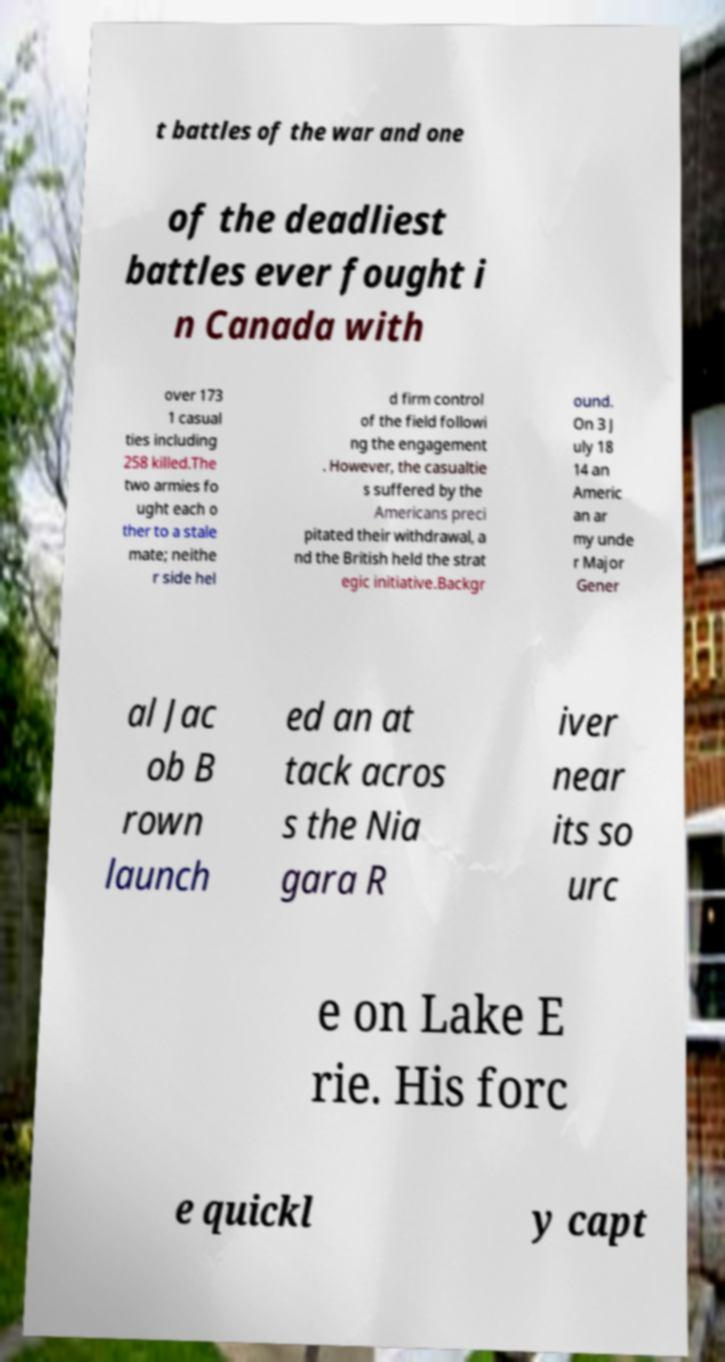Please identify and transcribe the text found in this image. t battles of the war and one of the deadliest battles ever fought i n Canada with over 173 1 casual ties including 258 killed.The two armies fo ught each o ther to a stale mate; neithe r side hel d firm control of the field followi ng the engagement . However, the casualtie s suffered by the Americans preci pitated their withdrawal, a nd the British held the strat egic initiative.Backgr ound. On 3 J uly 18 14 an Americ an ar my unde r Major Gener al Jac ob B rown launch ed an at tack acros s the Nia gara R iver near its so urc e on Lake E rie. His forc e quickl y capt 